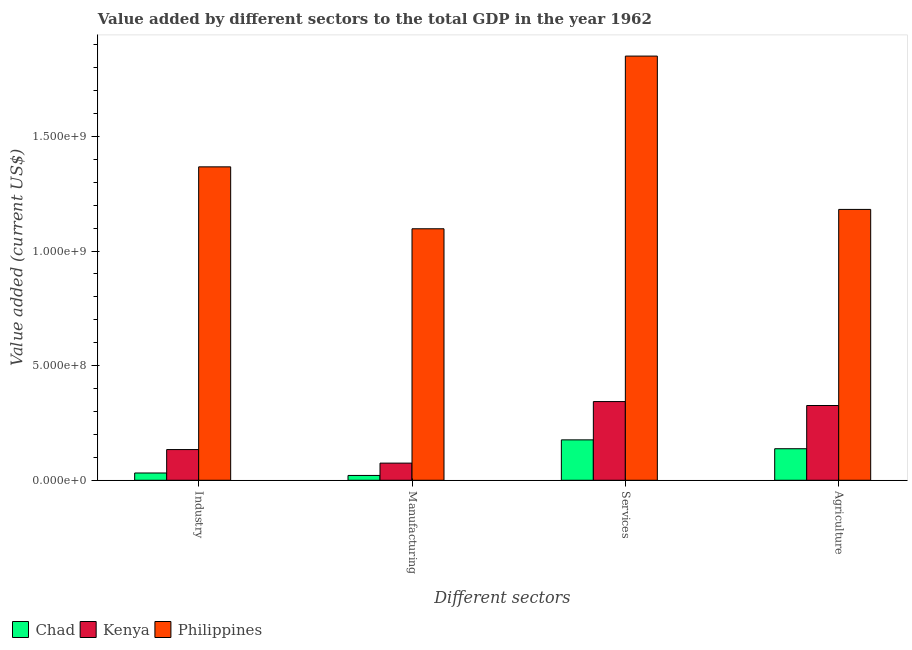Are the number of bars on each tick of the X-axis equal?
Provide a short and direct response. Yes. How many bars are there on the 3rd tick from the left?
Keep it short and to the point. 3. What is the label of the 1st group of bars from the left?
Your response must be concise. Industry. What is the value added by services sector in Philippines?
Offer a very short reply. 1.85e+09. Across all countries, what is the maximum value added by manufacturing sector?
Give a very brief answer. 1.10e+09. Across all countries, what is the minimum value added by agricultural sector?
Your answer should be very brief. 1.38e+08. In which country was the value added by industrial sector minimum?
Offer a very short reply. Chad. What is the total value added by agricultural sector in the graph?
Offer a very short reply. 1.65e+09. What is the difference between the value added by agricultural sector in Kenya and that in Philippines?
Offer a very short reply. -8.56e+08. What is the difference between the value added by manufacturing sector in Kenya and the value added by services sector in Chad?
Give a very brief answer. -1.01e+08. What is the average value added by agricultural sector per country?
Ensure brevity in your answer.  5.48e+08. What is the difference between the value added by services sector and value added by manufacturing sector in Kenya?
Make the answer very short. 2.68e+08. What is the ratio of the value added by agricultural sector in Chad to that in Kenya?
Offer a terse response. 0.42. What is the difference between the highest and the second highest value added by services sector?
Offer a very short reply. 1.51e+09. What is the difference between the highest and the lowest value added by services sector?
Give a very brief answer. 1.67e+09. What does the 2nd bar from the left in Services represents?
Your response must be concise. Kenya. What does the 2nd bar from the right in Services represents?
Ensure brevity in your answer.  Kenya. Is it the case that in every country, the sum of the value added by industrial sector and value added by manufacturing sector is greater than the value added by services sector?
Offer a very short reply. No. What is the difference between two consecutive major ticks on the Y-axis?
Make the answer very short. 5.00e+08. Does the graph contain any zero values?
Make the answer very short. No. Where does the legend appear in the graph?
Give a very brief answer. Bottom left. How are the legend labels stacked?
Give a very brief answer. Horizontal. What is the title of the graph?
Provide a succinct answer. Value added by different sectors to the total GDP in the year 1962. What is the label or title of the X-axis?
Your response must be concise. Different sectors. What is the label or title of the Y-axis?
Make the answer very short. Value added (current US$). What is the Value added (current US$) of Chad in Industry?
Provide a succinct answer. 3.17e+07. What is the Value added (current US$) in Kenya in Industry?
Give a very brief answer. 1.34e+08. What is the Value added (current US$) of Philippines in Industry?
Ensure brevity in your answer.  1.37e+09. What is the Value added (current US$) in Chad in Manufacturing?
Make the answer very short. 2.10e+07. What is the Value added (current US$) in Kenya in Manufacturing?
Your answer should be very brief. 7.48e+07. What is the Value added (current US$) in Philippines in Manufacturing?
Your answer should be compact. 1.10e+09. What is the Value added (current US$) of Chad in Services?
Your response must be concise. 1.76e+08. What is the Value added (current US$) in Kenya in Services?
Your answer should be compact. 3.43e+08. What is the Value added (current US$) of Philippines in Services?
Your response must be concise. 1.85e+09. What is the Value added (current US$) of Chad in Agriculture?
Provide a short and direct response. 1.38e+08. What is the Value added (current US$) of Kenya in Agriculture?
Give a very brief answer. 3.26e+08. What is the Value added (current US$) of Philippines in Agriculture?
Keep it short and to the point. 1.18e+09. Across all Different sectors, what is the maximum Value added (current US$) in Chad?
Offer a very short reply. 1.76e+08. Across all Different sectors, what is the maximum Value added (current US$) in Kenya?
Provide a succinct answer. 3.43e+08. Across all Different sectors, what is the maximum Value added (current US$) of Philippines?
Offer a terse response. 1.85e+09. Across all Different sectors, what is the minimum Value added (current US$) of Chad?
Keep it short and to the point. 2.10e+07. Across all Different sectors, what is the minimum Value added (current US$) of Kenya?
Offer a terse response. 7.48e+07. Across all Different sectors, what is the minimum Value added (current US$) in Philippines?
Offer a very short reply. 1.10e+09. What is the total Value added (current US$) of Chad in the graph?
Ensure brevity in your answer.  3.67e+08. What is the total Value added (current US$) of Kenya in the graph?
Provide a succinct answer. 8.78e+08. What is the total Value added (current US$) of Philippines in the graph?
Your answer should be compact. 5.50e+09. What is the difference between the Value added (current US$) of Chad in Industry and that in Manufacturing?
Your answer should be very brief. 1.07e+07. What is the difference between the Value added (current US$) of Kenya in Industry and that in Manufacturing?
Your answer should be very brief. 5.91e+07. What is the difference between the Value added (current US$) of Philippines in Industry and that in Manufacturing?
Your answer should be very brief. 2.70e+08. What is the difference between the Value added (current US$) of Chad in Industry and that in Services?
Keep it short and to the point. -1.45e+08. What is the difference between the Value added (current US$) of Kenya in Industry and that in Services?
Give a very brief answer. -2.09e+08. What is the difference between the Value added (current US$) in Philippines in Industry and that in Services?
Ensure brevity in your answer.  -4.83e+08. What is the difference between the Value added (current US$) of Chad in Industry and that in Agriculture?
Your response must be concise. -1.06e+08. What is the difference between the Value added (current US$) in Kenya in Industry and that in Agriculture?
Keep it short and to the point. -1.92e+08. What is the difference between the Value added (current US$) of Philippines in Industry and that in Agriculture?
Make the answer very short. 1.86e+08. What is the difference between the Value added (current US$) in Chad in Manufacturing and that in Services?
Offer a very short reply. -1.55e+08. What is the difference between the Value added (current US$) of Kenya in Manufacturing and that in Services?
Offer a terse response. -2.68e+08. What is the difference between the Value added (current US$) of Philippines in Manufacturing and that in Services?
Ensure brevity in your answer.  -7.53e+08. What is the difference between the Value added (current US$) of Chad in Manufacturing and that in Agriculture?
Make the answer very short. -1.17e+08. What is the difference between the Value added (current US$) in Kenya in Manufacturing and that in Agriculture?
Give a very brief answer. -2.51e+08. What is the difference between the Value added (current US$) of Philippines in Manufacturing and that in Agriculture?
Ensure brevity in your answer.  -8.44e+07. What is the difference between the Value added (current US$) of Chad in Services and that in Agriculture?
Provide a succinct answer. 3.87e+07. What is the difference between the Value added (current US$) of Kenya in Services and that in Agriculture?
Offer a very short reply. 1.72e+07. What is the difference between the Value added (current US$) in Philippines in Services and that in Agriculture?
Provide a short and direct response. 6.69e+08. What is the difference between the Value added (current US$) in Chad in Industry and the Value added (current US$) in Kenya in Manufacturing?
Make the answer very short. -4.31e+07. What is the difference between the Value added (current US$) of Chad in Industry and the Value added (current US$) of Philippines in Manufacturing?
Keep it short and to the point. -1.07e+09. What is the difference between the Value added (current US$) in Kenya in Industry and the Value added (current US$) in Philippines in Manufacturing?
Your response must be concise. -9.63e+08. What is the difference between the Value added (current US$) in Chad in Industry and the Value added (current US$) in Kenya in Services?
Your answer should be very brief. -3.12e+08. What is the difference between the Value added (current US$) in Chad in Industry and the Value added (current US$) in Philippines in Services?
Your answer should be very brief. -1.82e+09. What is the difference between the Value added (current US$) of Kenya in Industry and the Value added (current US$) of Philippines in Services?
Keep it short and to the point. -1.72e+09. What is the difference between the Value added (current US$) in Chad in Industry and the Value added (current US$) in Kenya in Agriculture?
Offer a terse response. -2.94e+08. What is the difference between the Value added (current US$) in Chad in Industry and the Value added (current US$) in Philippines in Agriculture?
Offer a very short reply. -1.15e+09. What is the difference between the Value added (current US$) in Kenya in Industry and the Value added (current US$) in Philippines in Agriculture?
Provide a short and direct response. -1.05e+09. What is the difference between the Value added (current US$) of Chad in Manufacturing and the Value added (current US$) of Kenya in Services?
Your response must be concise. -3.22e+08. What is the difference between the Value added (current US$) in Chad in Manufacturing and the Value added (current US$) in Philippines in Services?
Offer a terse response. -1.83e+09. What is the difference between the Value added (current US$) of Kenya in Manufacturing and the Value added (current US$) of Philippines in Services?
Your answer should be compact. -1.78e+09. What is the difference between the Value added (current US$) of Chad in Manufacturing and the Value added (current US$) of Kenya in Agriculture?
Ensure brevity in your answer.  -3.05e+08. What is the difference between the Value added (current US$) of Chad in Manufacturing and the Value added (current US$) of Philippines in Agriculture?
Your response must be concise. -1.16e+09. What is the difference between the Value added (current US$) of Kenya in Manufacturing and the Value added (current US$) of Philippines in Agriculture?
Your response must be concise. -1.11e+09. What is the difference between the Value added (current US$) of Chad in Services and the Value added (current US$) of Kenya in Agriculture?
Ensure brevity in your answer.  -1.50e+08. What is the difference between the Value added (current US$) of Chad in Services and the Value added (current US$) of Philippines in Agriculture?
Ensure brevity in your answer.  -1.01e+09. What is the difference between the Value added (current US$) in Kenya in Services and the Value added (current US$) in Philippines in Agriculture?
Provide a succinct answer. -8.38e+08. What is the average Value added (current US$) in Chad per Different sectors?
Offer a very short reply. 9.17e+07. What is the average Value added (current US$) of Kenya per Different sectors?
Provide a succinct answer. 2.20e+08. What is the average Value added (current US$) of Philippines per Different sectors?
Provide a short and direct response. 1.37e+09. What is the difference between the Value added (current US$) of Chad and Value added (current US$) of Kenya in Industry?
Keep it short and to the point. -1.02e+08. What is the difference between the Value added (current US$) in Chad and Value added (current US$) in Philippines in Industry?
Ensure brevity in your answer.  -1.34e+09. What is the difference between the Value added (current US$) of Kenya and Value added (current US$) of Philippines in Industry?
Give a very brief answer. -1.23e+09. What is the difference between the Value added (current US$) of Chad and Value added (current US$) of Kenya in Manufacturing?
Offer a very short reply. -5.38e+07. What is the difference between the Value added (current US$) of Chad and Value added (current US$) of Philippines in Manufacturing?
Your answer should be compact. -1.08e+09. What is the difference between the Value added (current US$) of Kenya and Value added (current US$) of Philippines in Manufacturing?
Your answer should be very brief. -1.02e+09. What is the difference between the Value added (current US$) of Chad and Value added (current US$) of Kenya in Services?
Ensure brevity in your answer.  -1.67e+08. What is the difference between the Value added (current US$) in Chad and Value added (current US$) in Philippines in Services?
Offer a terse response. -1.67e+09. What is the difference between the Value added (current US$) of Kenya and Value added (current US$) of Philippines in Services?
Keep it short and to the point. -1.51e+09. What is the difference between the Value added (current US$) of Chad and Value added (current US$) of Kenya in Agriculture?
Your response must be concise. -1.89e+08. What is the difference between the Value added (current US$) of Chad and Value added (current US$) of Philippines in Agriculture?
Make the answer very short. -1.04e+09. What is the difference between the Value added (current US$) of Kenya and Value added (current US$) of Philippines in Agriculture?
Your answer should be very brief. -8.56e+08. What is the ratio of the Value added (current US$) in Chad in Industry to that in Manufacturing?
Your response must be concise. 1.51. What is the ratio of the Value added (current US$) in Kenya in Industry to that in Manufacturing?
Your answer should be very brief. 1.79. What is the ratio of the Value added (current US$) of Philippines in Industry to that in Manufacturing?
Your answer should be very brief. 1.25. What is the ratio of the Value added (current US$) of Chad in Industry to that in Services?
Keep it short and to the point. 0.18. What is the ratio of the Value added (current US$) in Kenya in Industry to that in Services?
Your answer should be very brief. 0.39. What is the ratio of the Value added (current US$) of Philippines in Industry to that in Services?
Keep it short and to the point. 0.74. What is the ratio of the Value added (current US$) in Chad in Industry to that in Agriculture?
Your response must be concise. 0.23. What is the ratio of the Value added (current US$) in Kenya in Industry to that in Agriculture?
Provide a short and direct response. 0.41. What is the ratio of the Value added (current US$) of Philippines in Industry to that in Agriculture?
Provide a succinct answer. 1.16. What is the ratio of the Value added (current US$) of Chad in Manufacturing to that in Services?
Make the answer very short. 0.12. What is the ratio of the Value added (current US$) of Kenya in Manufacturing to that in Services?
Provide a succinct answer. 0.22. What is the ratio of the Value added (current US$) of Philippines in Manufacturing to that in Services?
Your answer should be very brief. 0.59. What is the ratio of the Value added (current US$) of Chad in Manufacturing to that in Agriculture?
Keep it short and to the point. 0.15. What is the ratio of the Value added (current US$) in Kenya in Manufacturing to that in Agriculture?
Ensure brevity in your answer.  0.23. What is the ratio of the Value added (current US$) in Philippines in Manufacturing to that in Agriculture?
Your answer should be very brief. 0.93. What is the ratio of the Value added (current US$) in Chad in Services to that in Agriculture?
Provide a short and direct response. 1.28. What is the ratio of the Value added (current US$) in Kenya in Services to that in Agriculture?
Your response must be concise. 1.05. What is the ratio of the Value added (current US$) in Philippines in Services to that in Agriculture?
Keep it short and to the point. 1.57. What is the difference between the highest and the second highest Value added (current US$) of Chad?
Give a very brief answer. 3.87e+07. What is the difference between the highest and the second highest Value added (current US$) of Kenya?
Offer a terse response. 1.72e+07. What is the difference between the highest and the second highest Value added (current US$) in Philippines?
Offer a terse response. 4.83e+08. What is the difference between the highest and the lowest Value added (current US$) of Chad?
Provide a succinct answer. 1.55e+08. What is the difference between the highest and the lowest Value added (current US$) of Kenya?
Your answer should be very brief. 2.68e+08. What is the difference between the highest and the lowest Value added (current US$) of Philippines?
Your response must be concise. 7.53e+08. 